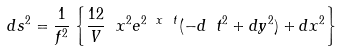Convert formula to latex. <formula><loc_0><loc_0><loc_500><loc_500>d s ^ { 2 } = \frac { 1 } { f ^ { 2 } } \left \{ \frac { 1 2 } { V } \ x ^ { 2 } e ^ { 2 \ x \ t } ( - d \ t ^ { 2 } + d y ^ { 2 } ) + d { x } ^ { 2 } \right \}</formula> 